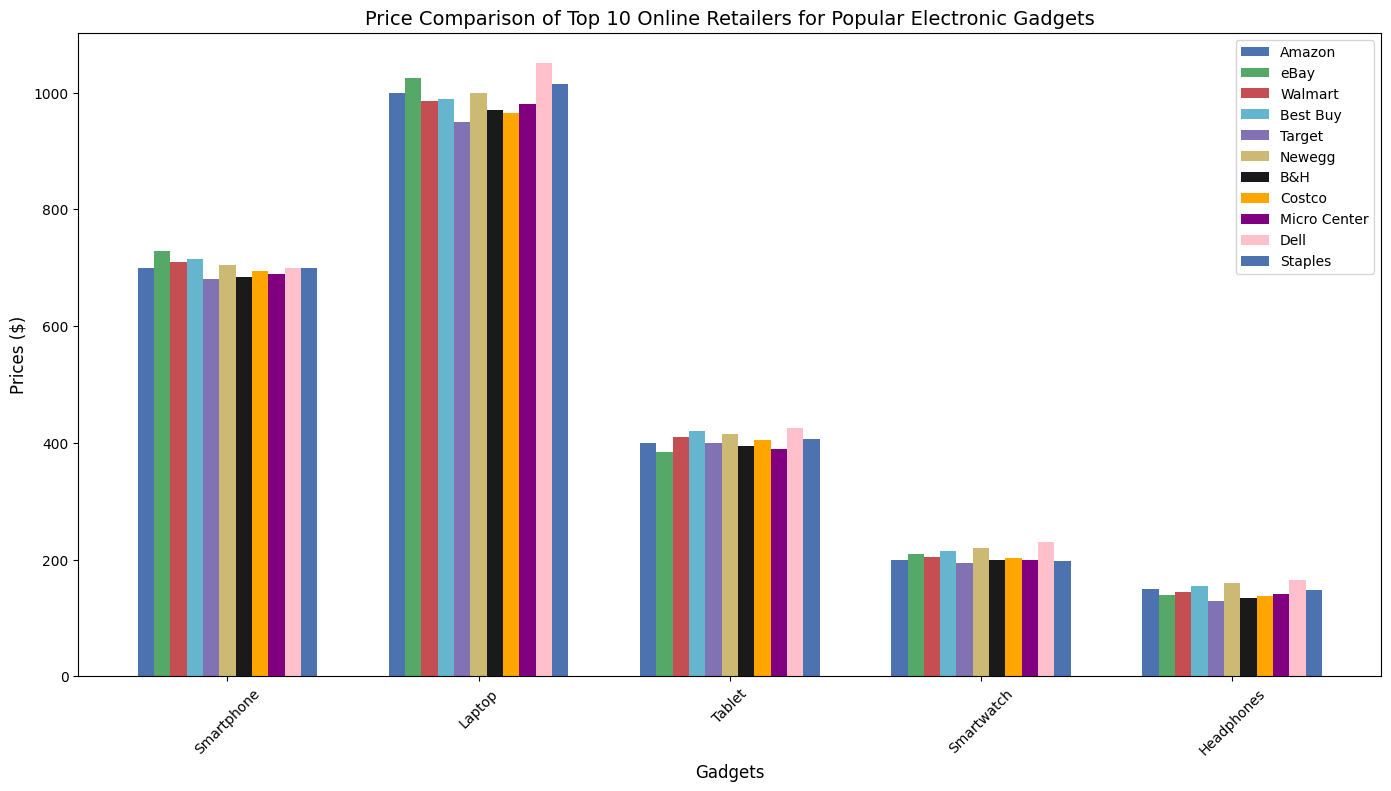What's the cheapest retailer for a smartphone? Scan the bars corresponding to 'Smartphone' for all retailers and compare their heights to determine which one is the shortest, indicating the lowest price.
Answer: Target Which retailer has the highest priced laptop? Look at the 'Laptop' category bars across all retailers and find the tallest bar, indicating the highest price.
Answer: Dell How much more expensive is the tablet from Best Buy compared to Amazon? Find the 'Tablet' bar heights for Best Buy and Amazon, and calculate the difference (420 - 399).
Answer: $21 What is the average price of headphones across all retailers? Sum the values of all 'Headphones' prices and divide by the number of retailers: (150 + 140 + 145 + 155 + 130 + 160 + 135 + 138 + 142 + 165 + 148) / 11.
Answer: $145.18 Which retailer offers the cheapest smartwatch? Compare the bar heights for 'Smartwatch' across all retailers to find the shortest one.
Answer: Amazon and Target (tie) Compare the price of a tablet at Walmart to B&H. How much difference is there? Look at the 'Tablet' bar heights for Walmart and B&H and calculate the difference (410 - 395).
Answer: $15 What's the median price of a laptop? Arrange all the 'Laptop' prices in ascending order and find the middle value: [950, 965, 970, 980, 985, 990, 999, 1000, 1015, 1025, 1050]. The middle value is the 6th value.
Answer: $990 Which retailer offers the most expensive smartwatch? Identify the tallest bar for the 'Smartwatch' category across all retailers.
Answer: Dell Compare the prices of headphones from Newegg and Costco. Which one is cheaper and by how much? Look at the 'Headphones' bar heights for Newegg and Costco and subtract the lower price from the higher price (160 - 138).
Answer: Costco by $22 What's the difference in the price of a smartphone between Amazon and Micro Center? Find the 'Smartphone' bar heights for Amazon and Micro Center and calculate the difference (699 - 690).
Answer: $9 